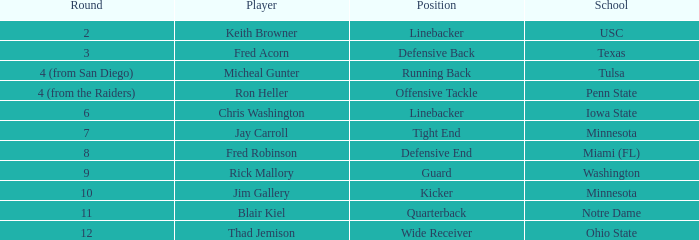What is the overall selection number in the second round? 1.0. 